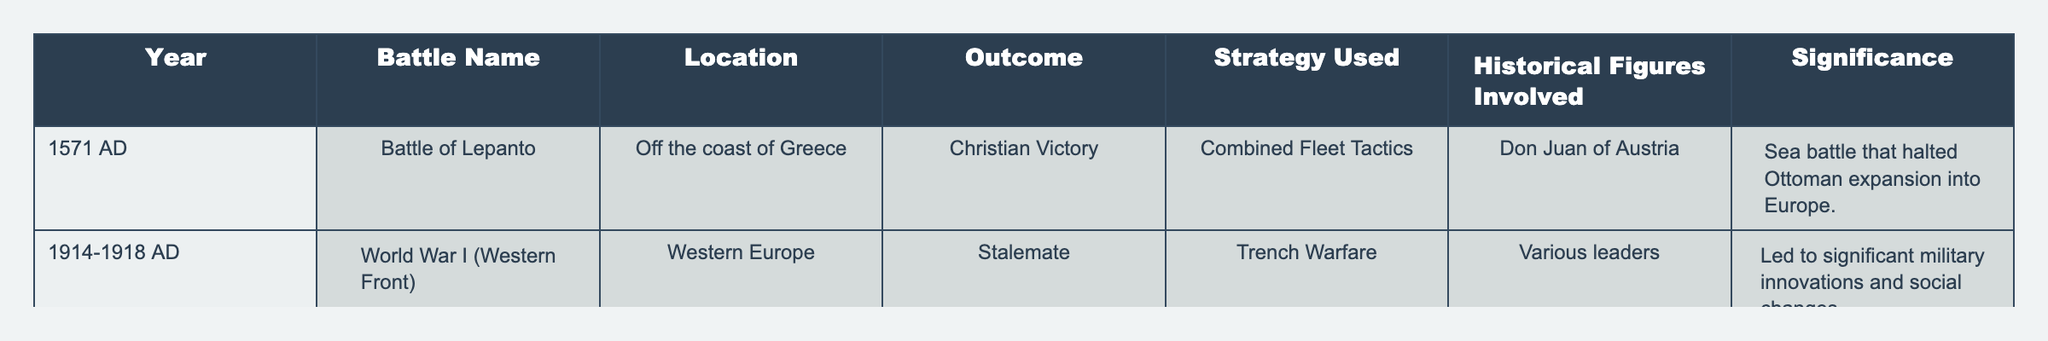What was the outcome of the Battle of Lepanto? The table specifies that the Battle of Lepanto had a Christian Victory as its outcome, which is directly stated in the "Outcome" column corresponding to that battle.
Answer: Christian Victory Which strategy was used in World War I (Western Front)? According to the table, the strategy used in World War I on the Western Front was Trench Warfare, as indicated in the "Strategy Used" column for that entry.
Answer: Trench Warfare Did the Battle of Lepanto involve significant historical figures? Yes, the table mentions Don Juan of Austria as a historical figure involved in the Battle of Lepanto, confirming that significant figures were indeed involved.
Answer: Yes What is the significance of the Battle of Lepanto? The "Significance" column states that the Battle of Lepanto is significant because it halted Ottoman expansion into Europe, providing a clear reason for its historical importance.
Answer: Halted Ottoman expansion into Europe How many battles resulted in a Christian Victory listed in the table? There is only one battle listed that is a Christian Victory, which is the Battle of Lepanto. Since this is the only indication in the table, the total count is one.
Answer: 1 What strategy was employed in both battles mentioned in the table? The table shows two battles: the Battle of Lepanto used Combined Fleet Tactics, and World War I (Western Front) used Trench Warfare. Therefore, there is no single strategy common to both, indicating diversity in strategies.
Answer: None What can be inferred about the innovation in military tactics based on the outcomes and strategies from the table? The outcomes and strategies suggest that there was a shift from traditional naval tactics in the Battle of Lepanto to modern trench warfare in World War I, indicating an evolution in military tactics over time. This reflects the changing nature of warfare strategies.
Answer: Evolution of military tactics Which battle involved multiple leaders? The table references the World War I (Western Front) as involving various leaders, while the Battle of Lepanto involved a specific historical figure.
Answer: World War I (Western Front) What strategy was not used in the Battle of Lepanto? The strategy of Trench Warfare was not used in the Battle of Lepanto since it occurred at sea, while Trench Warfare is associated with land battles in World War I.
Answer: Trench Warfare How many years apart were the Battle of Lepanto and World War I? The Battle of Lepanto occurred in 1571 and World War I spanned from 1914 to 1918, making it approximately 343 years apart. This calculation involves subtracting 1571 from the starting year of World War I.
Answer: 343 years 